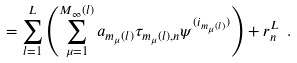<formula> <loc_0><loc_0><loc_500><loc_500>= \sum _ { l = 1 } ^ { L } \left ( \sum _ { \mu = 1 } ^ { M _ { \infty } ( l ) } a _ { m _ { \mu } ( l ) } \tau _ { m _ { \mu } ( l ) , n } \psi ^ { ( i _ { m _ { \mu } ( l ) } ) } \right ) + r _ { n } ^ { L } \ .</formula> 